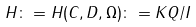<formula> <loc_0><loc_0><loc_500><loc_500>H \colon = H ( C , D , \Omega ) \colon = K Q / I</formula> 